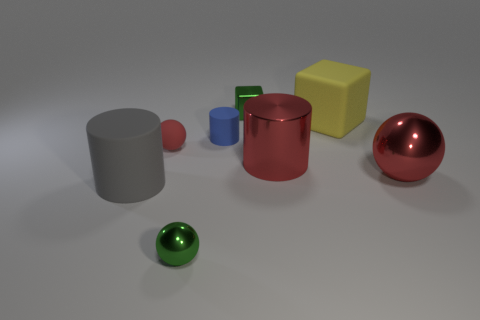Subtract all large gray cylinders. How many cylinders are left? 2 Add 1 blue objects. How many objects exist? 9 Subtract all green spheres. How many spheres are left? 2 Subtract all cylinders. How many objects are left? 5 Subtract 1 spheres. How many spheres are left? 2 Subtract all yellow cubes. How many red balls are left? 2 Add 5 tiny balls. How many tiny balls are left? 7 Add 7 yellow things. How many yellow things exist? 8 Subtract 0 blue spheres. How many objects are left? 8 Subtract all gray balls. Subtract all blue cubes. How many balls are left? 3 